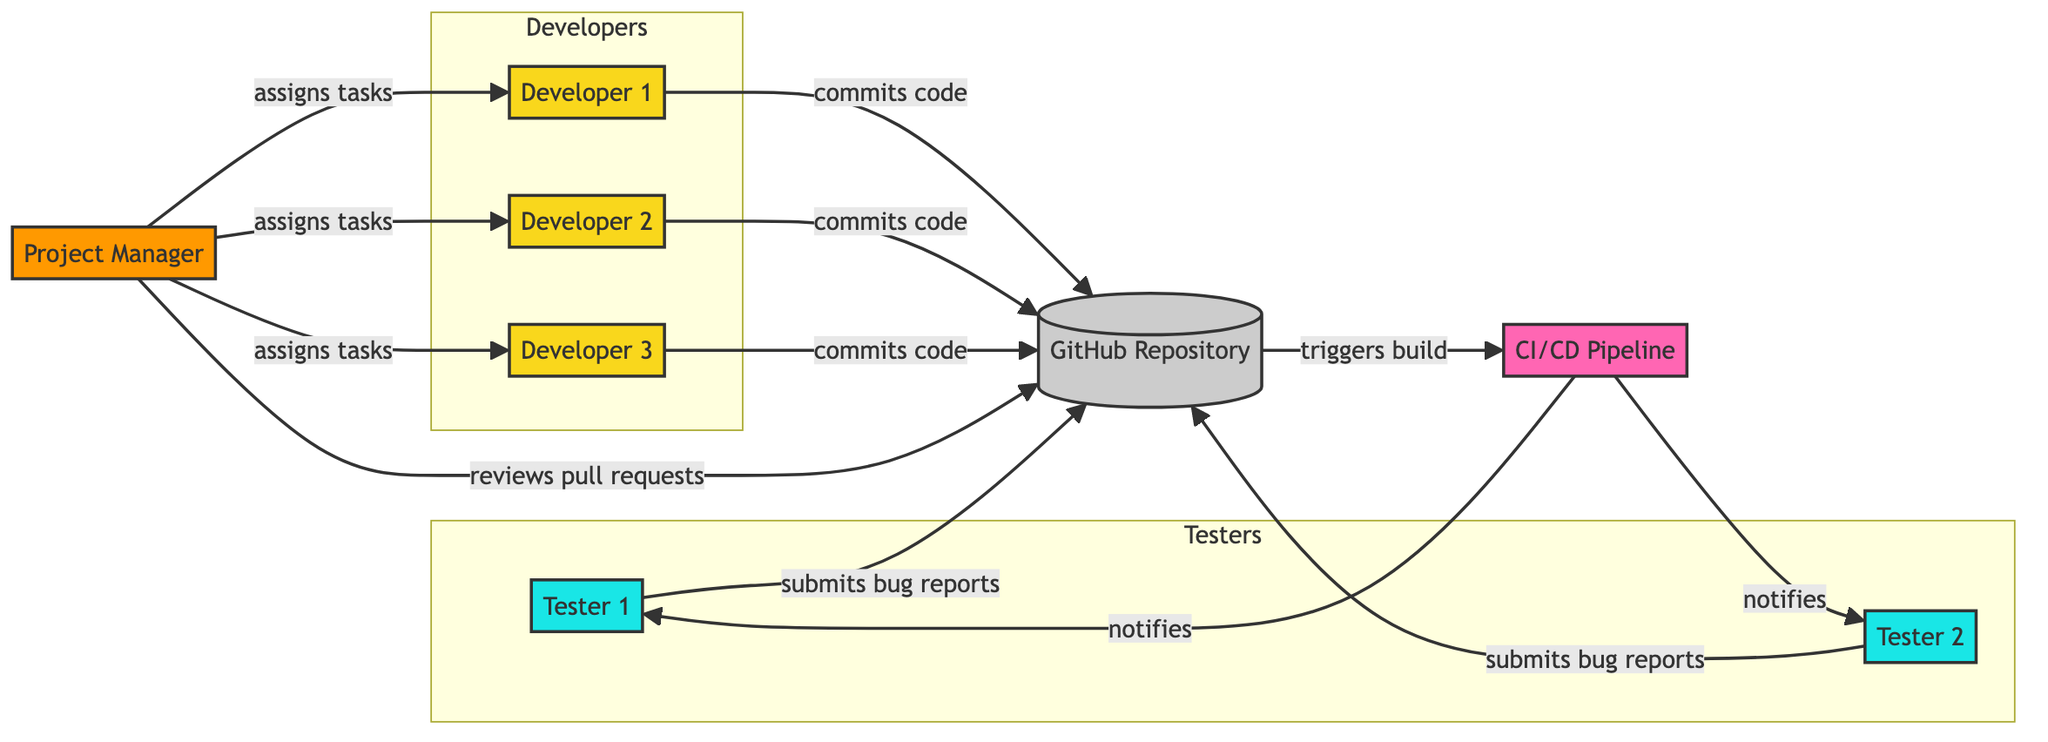What is the total number of nodes in the diagram? The diagram lists eight distinct entities, including developers, testers, the project manager, the repository, and the CI/CD pipeline. Counting each unique node, we find a total of eight.
Answer: eight How many developers are represented in the diagram? The diagram identifies three developers: Developer 1, Developer 2, and Developer 3, each playing a unique role in the software development process.
Answer: three What action do developers take towards the GitHub Repository? Each developer in the diagram commits code to the GitHub Repository, signifying their role in contributing to the shared codebase of the open-source project.
Answer: commits code Which node does the CI/CD Pipeline notify? The CI/CD pipeline sends notifications to both Tester 1 and Tester 2 after a build is triggered, indicating that testing is required following each successful build.
Answer: Tester 1 and Tester 2 How many edges are there in total in the diagram? By examining the diagram, we can count the connections, or edges, between nodes, finding a total of ten edges that delineate the workflow and communication paths among team members.
Answer: ten What role does the Project Manager have concerning the developers? The Project Manager is responsible for assigning tasks to each of the three developers, illustrating the managerial role in guiding the development process.
Answer: assigns tasks Which component triggers a build after code is committed? The GitHub Repository acts as the pivotal component that triggers the CI/CD pipeline to initiate a build process whenever code is committed by any of the developers.
Answer: CI/CD Pipeline What is the primary purpose of the edges leading from testers to the repository? The edges connecting the testers to the repository indicate their function of submitting bug reports, which highlights their critical role in ensuring code quality by identifying issues.
Answer: submits bug reports 